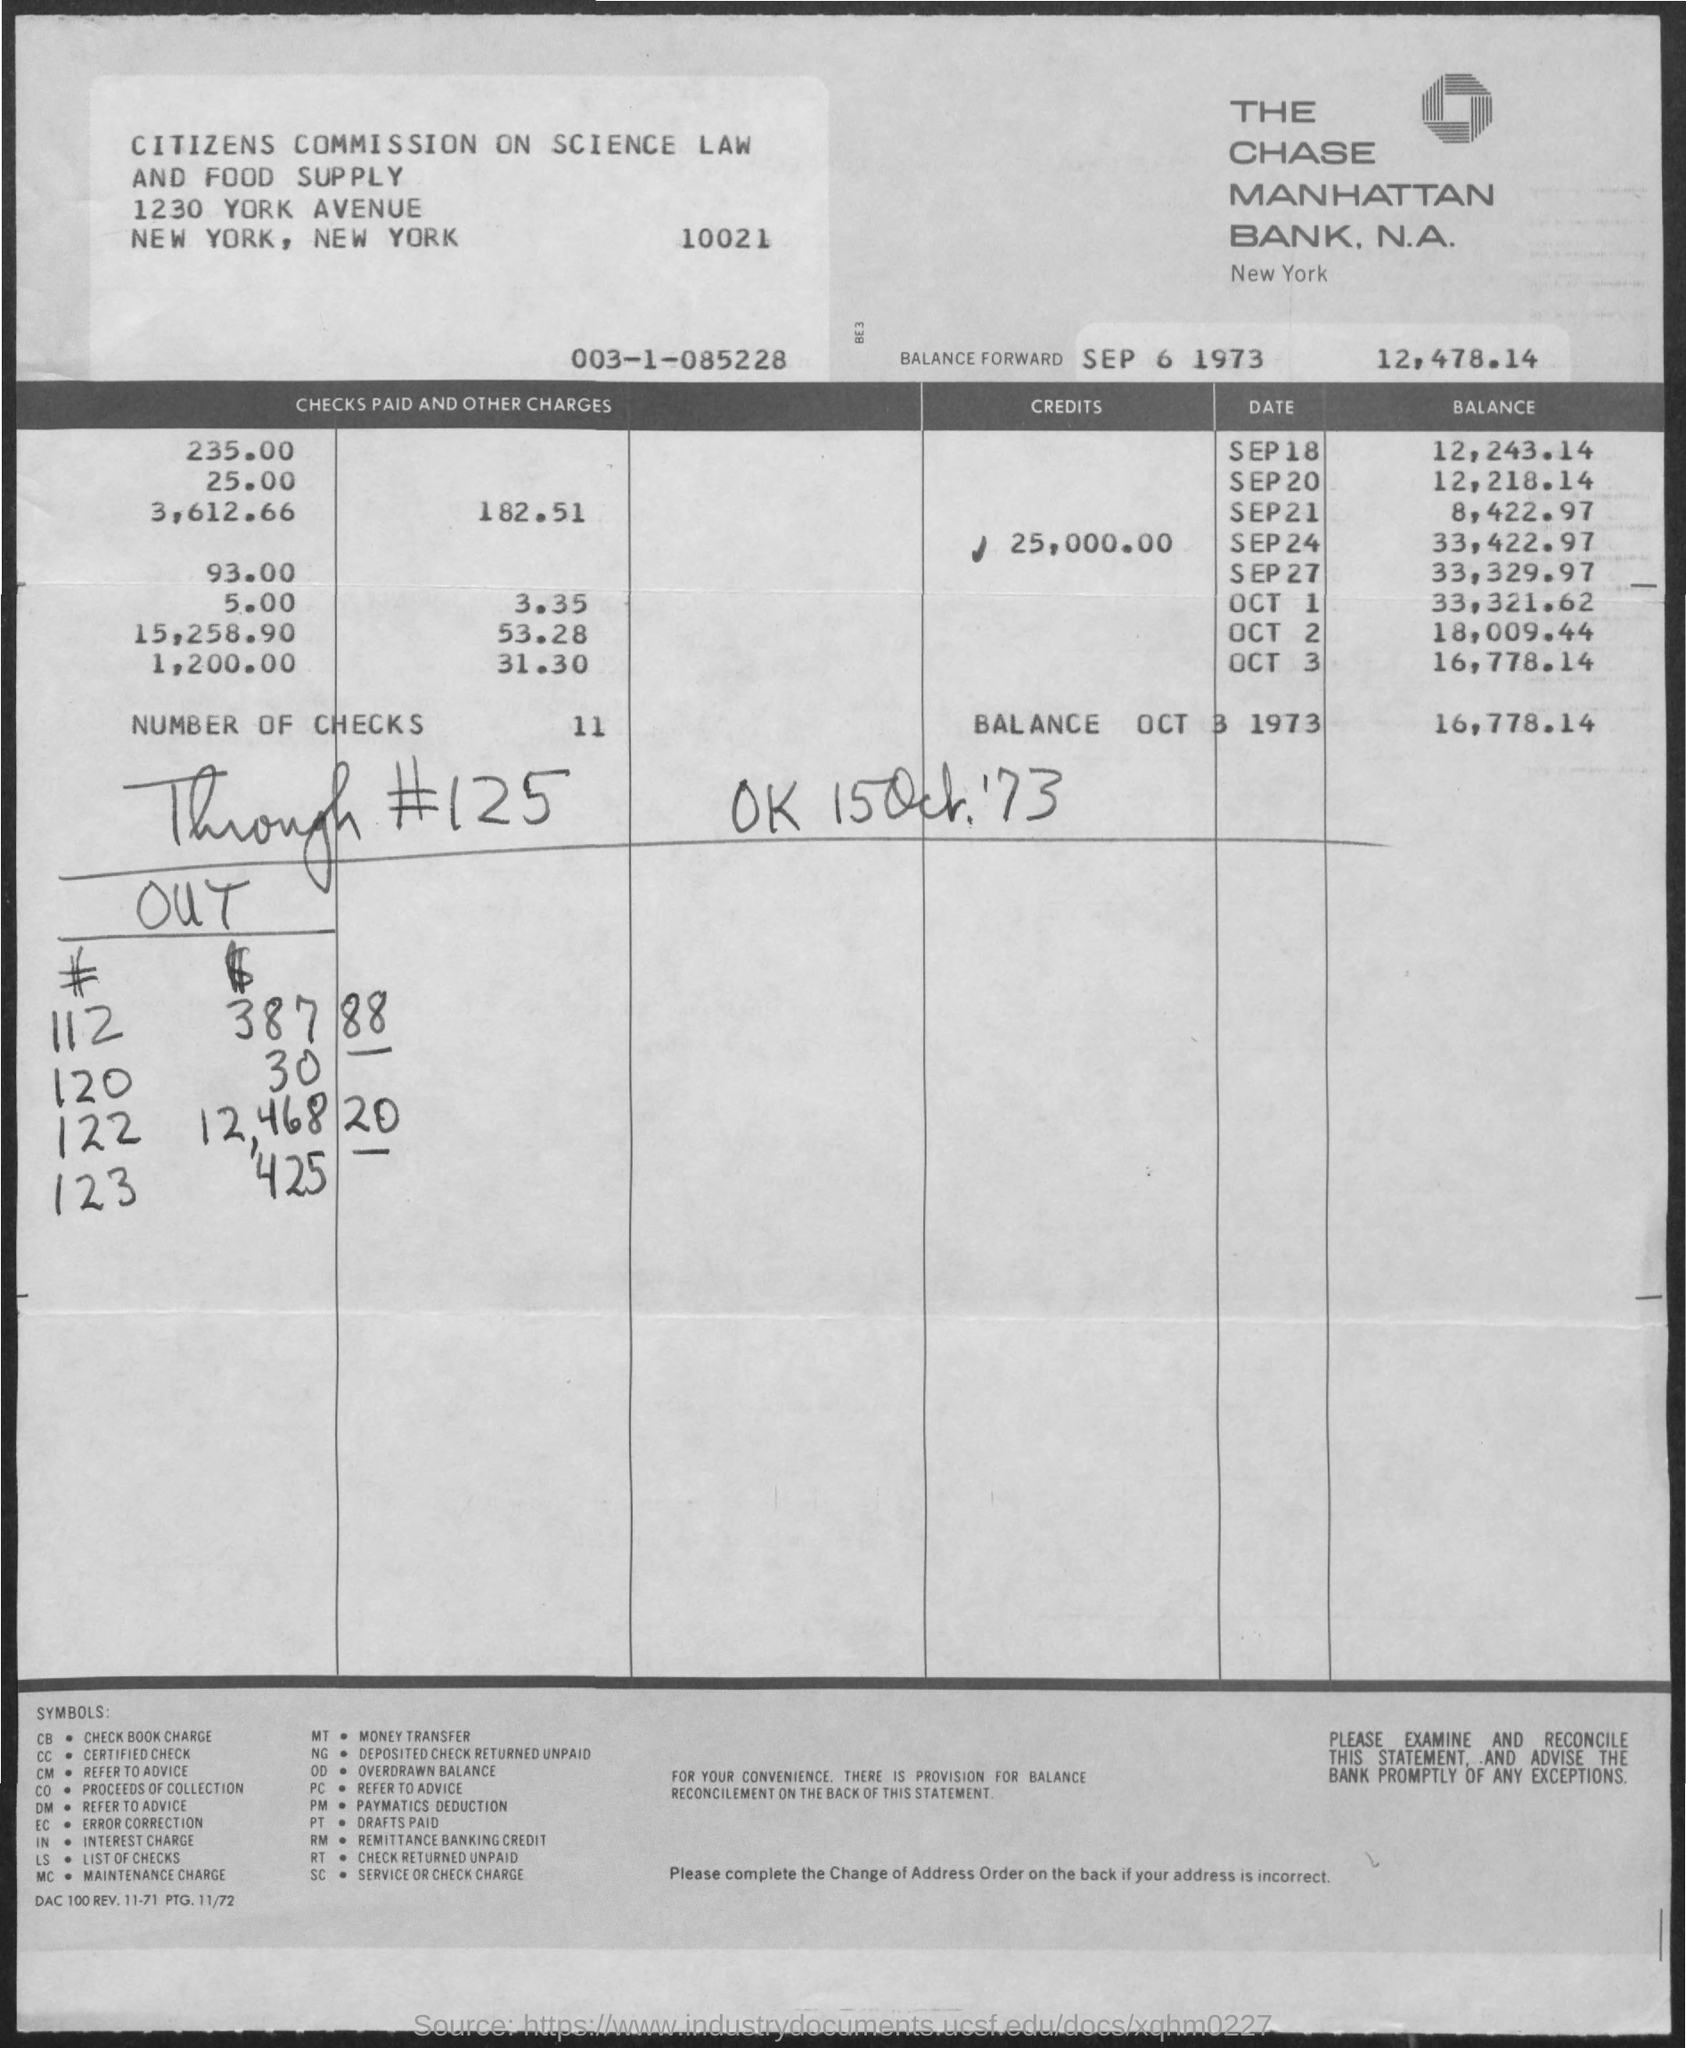What is the bank name?
Give a very brief answer. The chase manhattan bank, n.a. In which city is the Chase Manhattan bank?
Your answer should be very brief. New york. How much is the balance as on october 3 1973?
Your answer should be very brief. 16,778.14. What is the number of checks?
Offer a terse response. 11. Which city is the citizens commission on science law in?
Your answer should be very brief. New york. How much is the credits?
Your response must be concise. 25,000.00. How much is the balance forward as on sep 6 1973?
Give a very brief answer. 12,478.14. 